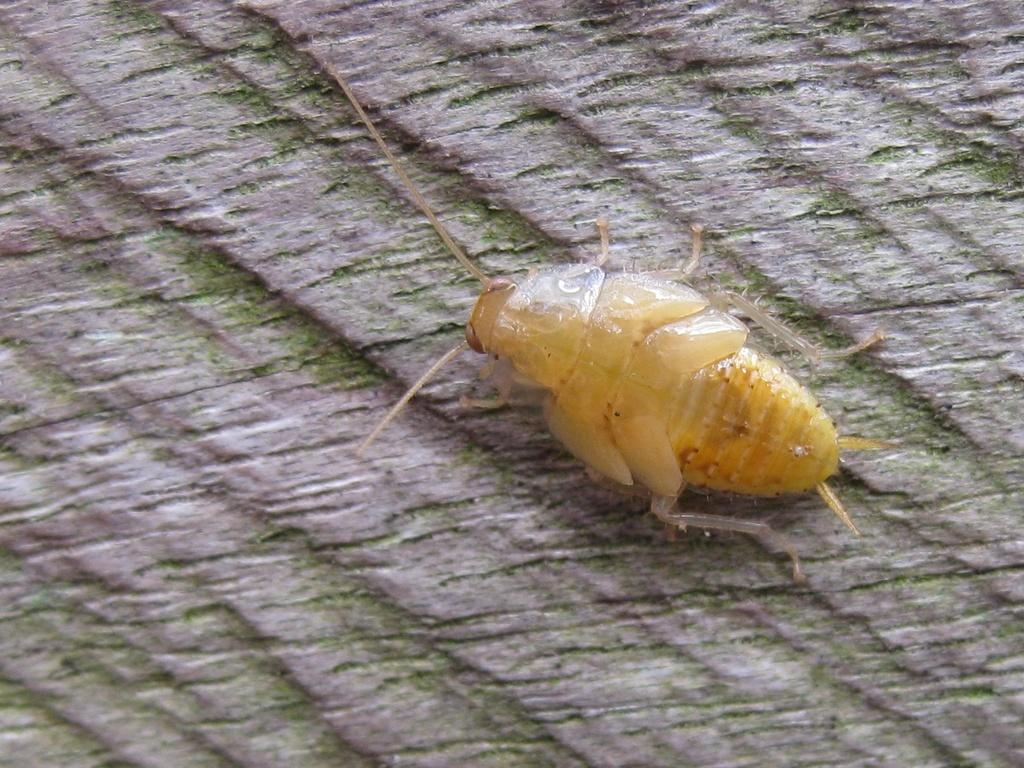What type of creature can be seen in the image? There is an insect in the image. Where is the insect located in the image? The insect is on the bark of a tree. What type of flowers can be seen growing in the shade in the image? There are no flowers present in the image; it features an insect on the bark of a tree. 